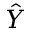<formula> <loc_0><loc_0><loc_500><loc_500>\hat { Y }</formula> 